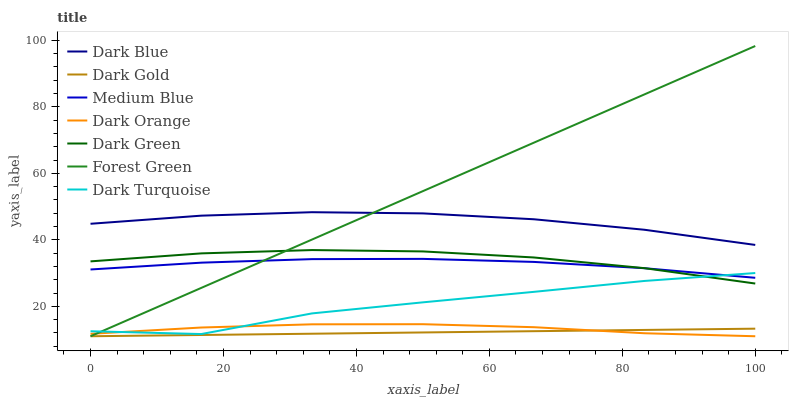Does Dark Gold have the minimum area under the curve?
Answer yes or no. Yes. Does Forest Green have the maximum area under the curve?
Answer yes or no. Yes. Does Dark Turquoise have the minimum area under the curve?
Answer yes or no. No. Does Dark Turquoise have the maximum area under the curve?
Answer yes or no. No. Is Dark Gold the smoothest?
Answer yes or no. Yes. Is Dark Turquoise the roughest?
Answer yes or no. Yes. Is Dark Turquoise the smoothest?
Answer yes or no. No. Is Dark Gold the roughest?
Answer yes or no. No. Does Dark Orange have the lowest value?
Answer yes or no. Yes. Does Dark Turquoise have the lowest value?
Answer yes or no. No. Does Forest Green have the highest value?
Answer yes or no. Yes. Does Dark Turquoise have the highest value?
Answer yes or no. No. Is Medium Blue less than Dark Blue?
Answer yes or no. Yes. Is Medium Blue greater than Dark Orange?
Answer yes or no. Yes. Does Forest Green intersect Dark Turquoise?
Answer yes or no. Yes. Is Forest Green less than Dark Turquoise?
Answer yes or no. No. Is Forest Green greater than Dark Turquoise?
Answer yes or no. No. Does Medium Blue intersect Dark Blue?
Answer yes or no. No. 